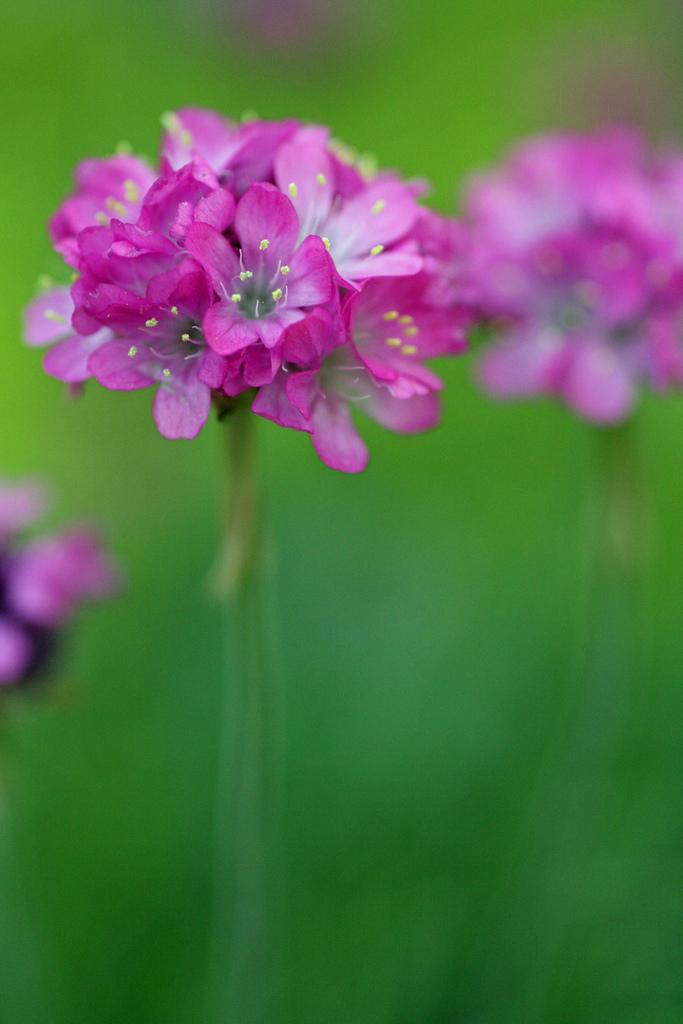What type of flowers are in the foreground of the image? There are pink color flowers in the foreground of the image. Can you describe the background of the image? The background of the image is blurry. What type of cloth is being used to trick the flowers in the image? There is no cloth or trickery involving the flowers in the image; they are simply pink color flowers in the foreground. 